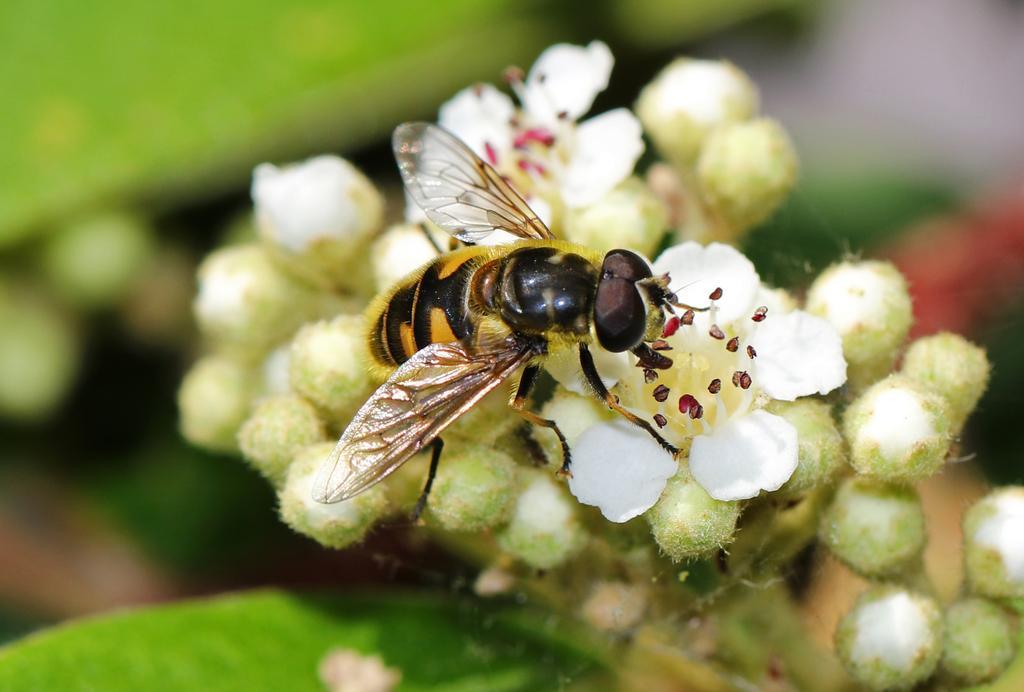Please provide a concise description of this image. In this image, we can see flowers and honey bee. Background there is a blur view. Here we can see green color. 